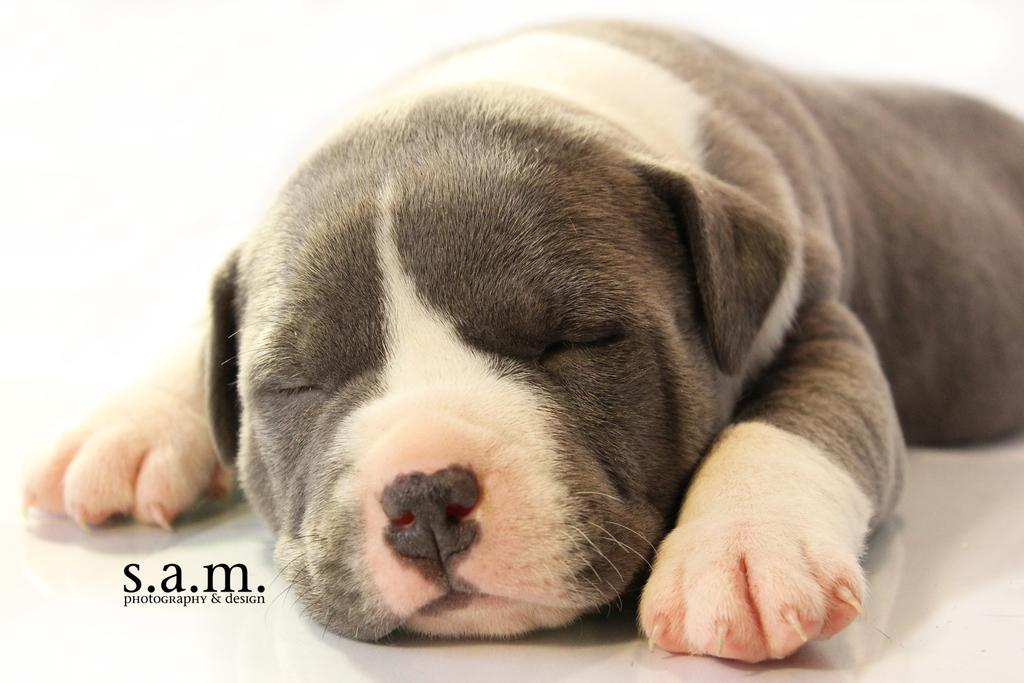What type of animal is present in the image? There is a dog in the image. What is the dog doing in the image? The dog is lying on the surface. Can you see any monkeys playing in the field with grapes in the image? There are no monkeys, fields, or grapes present in the image; it features a dog lying on a surface. 